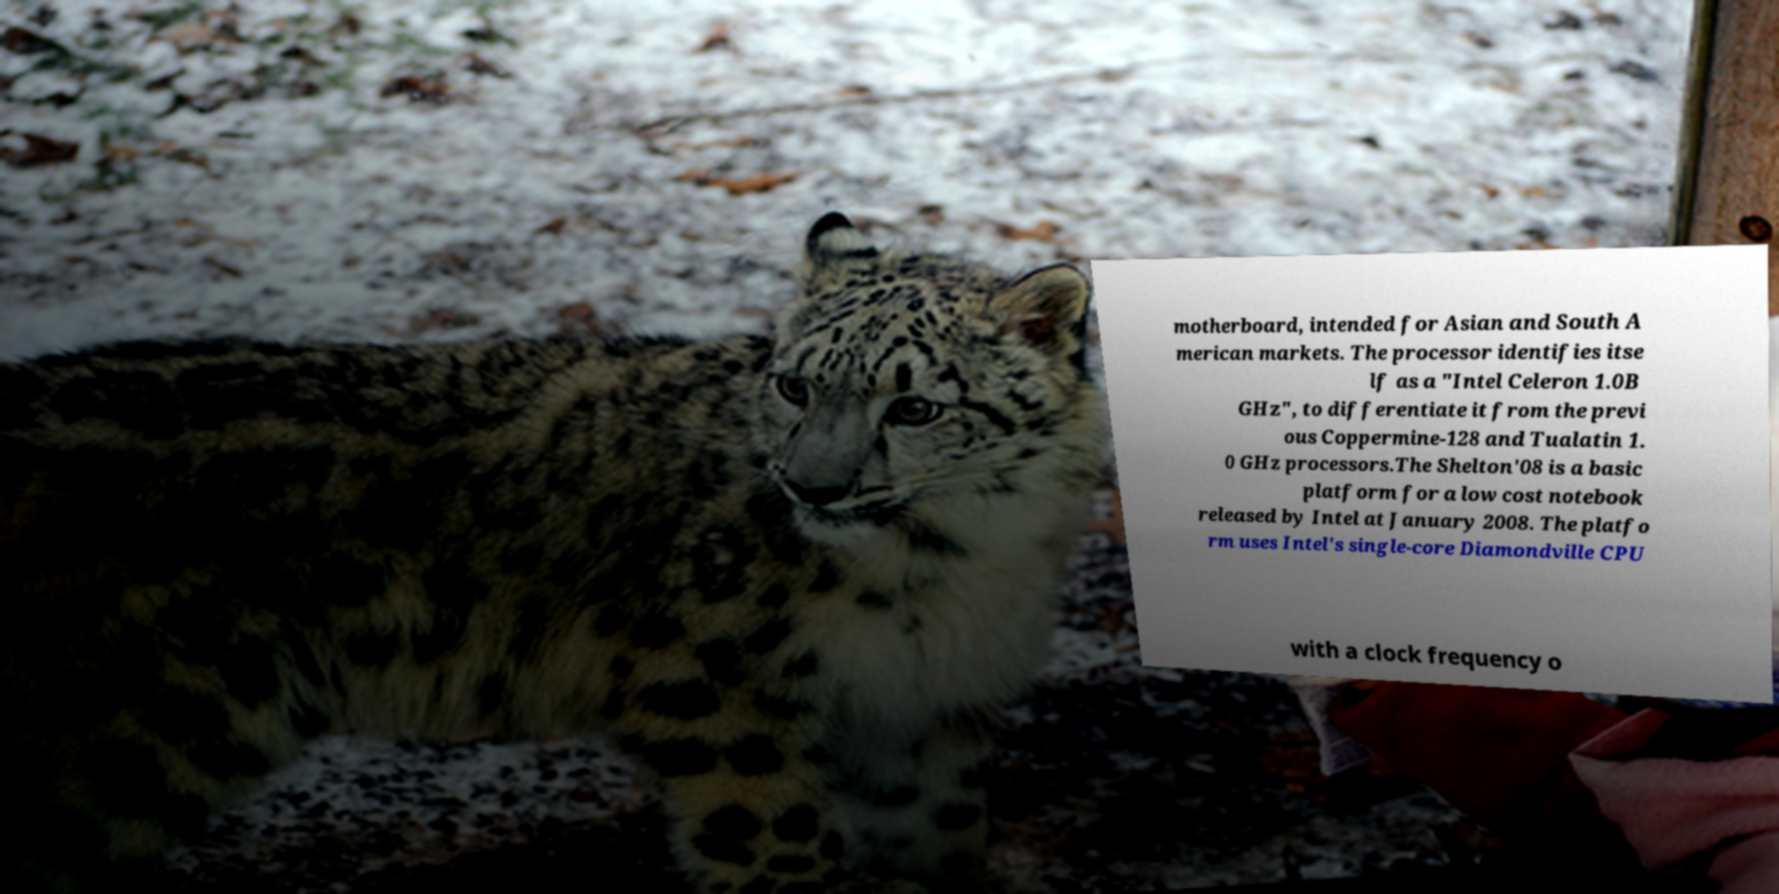Can you accurately transcribe the text from the provided image for me? motherboard, intended for Asian and South A merican markets. The processor identifies itse lf as a "Intel Celeron 1.0B GHz", to differentiate it from the previ ous Coppermine-128 and Tualatin 1. 0 GHz processors.The Shelton'08 is a basic platform for a low cost notebook released by Intel at January 2008. The platfo rm uses Intel's single-core Diamondville CPU with a clock frequency o 